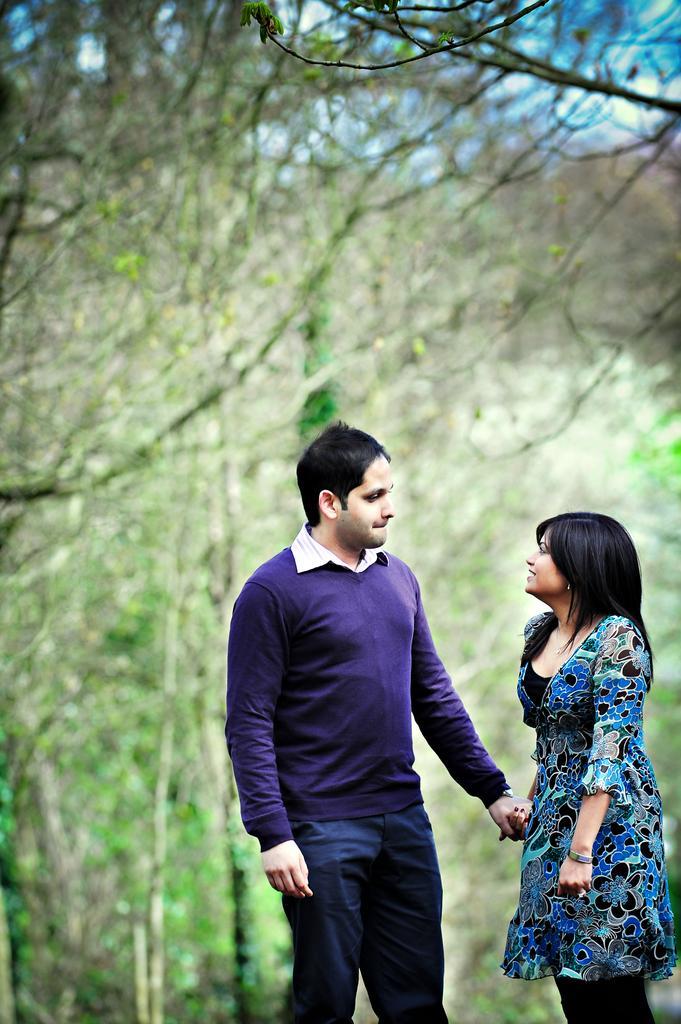In one or two sentences, can you explain what this image depicts? In this image we can see there are two persons standing and holding the hands. In the background, we can see the trees. 